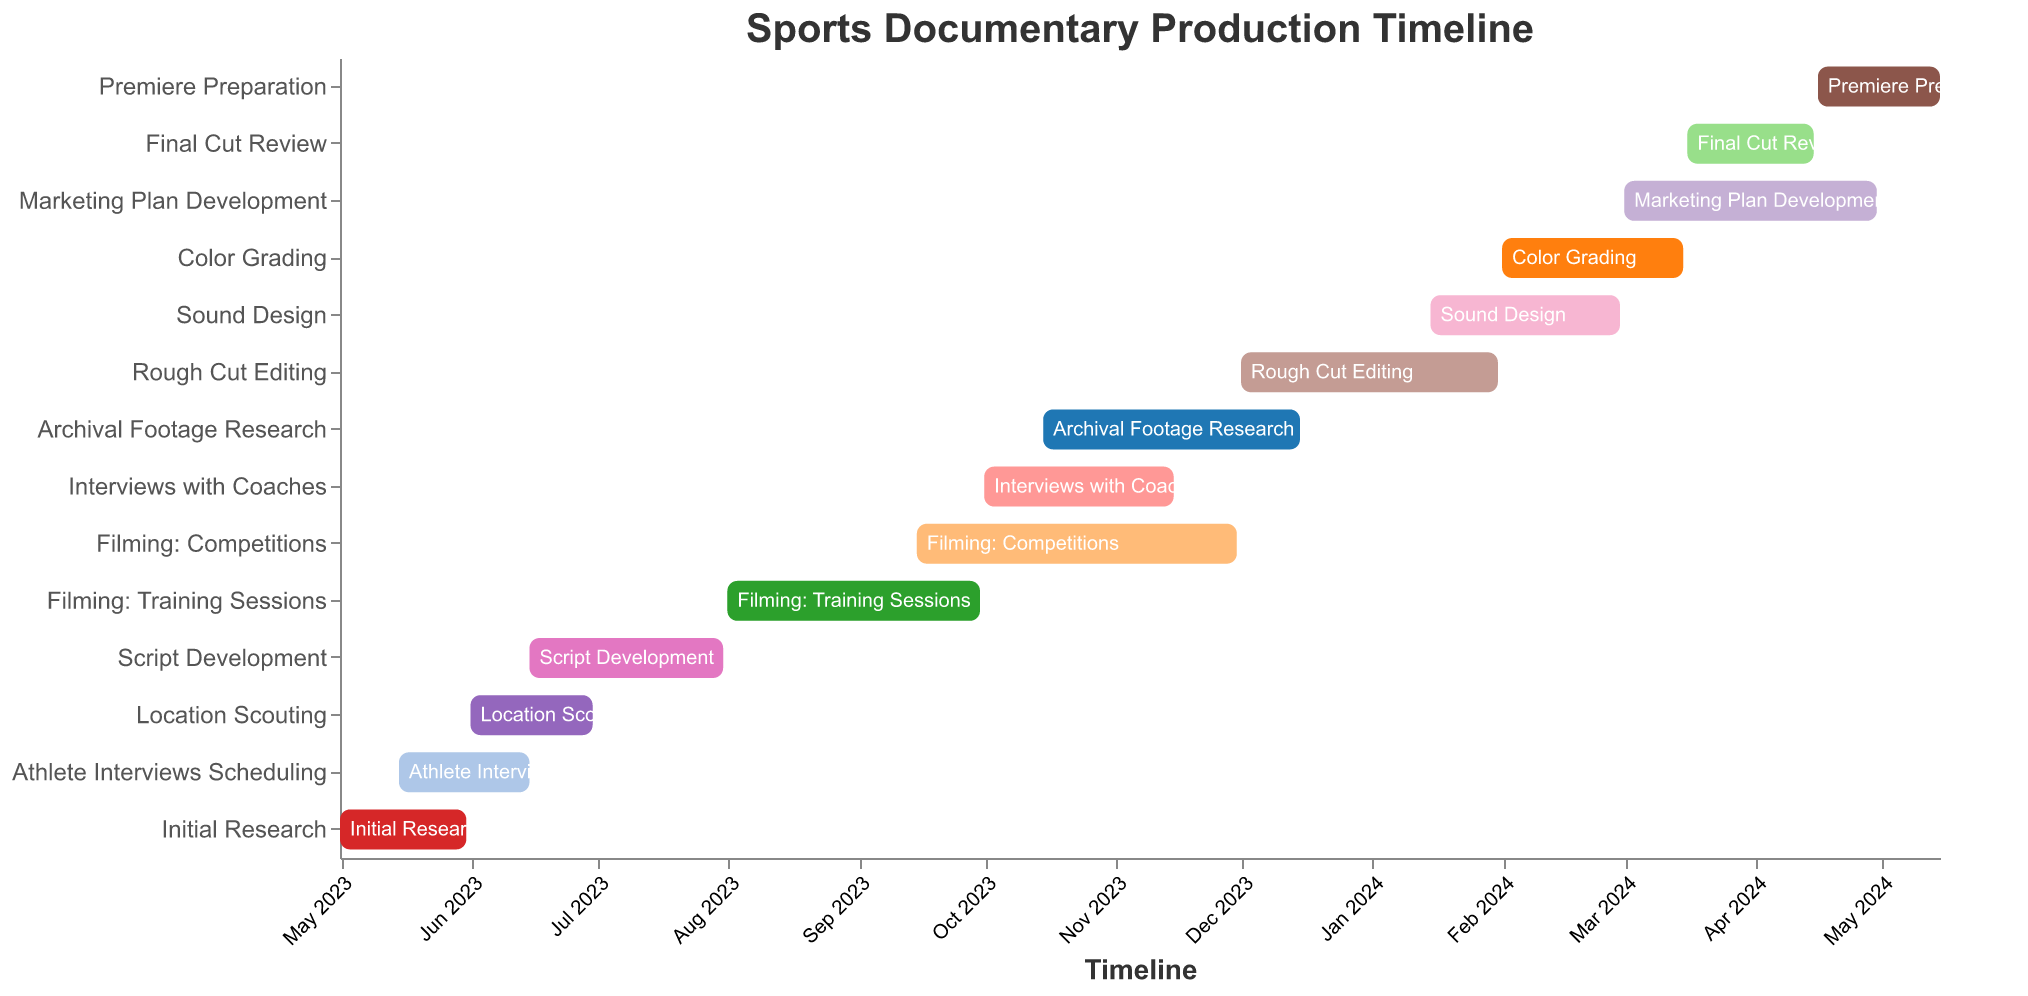What is the title of the chart? The title is at the top of the chart and it reads "Sports Documentary Production Timeline".
Answer: Sports Documentary Production Timeline Which task starts immediately after "Initial Research"? By looking at the Gantt chart, "Athlete Interviews Scheduling" starts on 2023-05-15 which is within the period of "Initial Research". The next new task to start after "Initial Research" ends on 2023-05-31 is "Location Scouting" starting on 2023-06-01.
Answer: Location Scouting How long does the "Script Development" phase last? According to the Gantt Chart, the "Script Development" phase starts on 2023-06-15 and ends on 2023-07-31. The number of days between these two dates is 46 days.
Answer: 46 days Which task lasts the longest and how long is it? By comparing the duration (end date - start date) of all tasks, "Filming: Competitions" has the longest duration, from 2023-09-15 to 2023-11-30, lasting 76 days.
Answer: Filming: Competitions, 76 days Which two tasks overlap entirely? Looking at the chart, "Interviews with Coaches" (2023-10-01 to 2023-11-15) and "Filming: Competitions" (2023-09-15 to 2023-11-30) have overlapping periods but none overlap entirely. Next overlapping tasks are "Sound Design" (2024-01-15 to 2024-02-29) and "Rough Cut Editing" (2023-12-01 to 2024-01-31)
Answer: None entirely but "Sound Design" and "Rough Cut Editing" do overlap What is the total duration of the production timeline? The entire timeline stretches from the start date of "Initial Research" (2023-05-01) to the end date of "Premiere Preparation" (2024-05-15). This spans 381 days in total.
Answer: 381 days Which task starts first and which one ends last? The first task, "Initial Research", starts on 2023-05-01, and the last task, "Premiere Preparation", ends on 2024-05-15.
Answer: Initial Research; Premiere Preparation Does "Final Cut Review" overlap with "Marketing Plan Development"? Checking both "Final Cut Review" (2024-03-16 to 2024-04-15) and "Marketing Plan Development" (2024-03-01 to 2024-04-30), there is an overlap between these two tasks from 2024-03-16 to 2024-04-15.
Answer: Yes How many tasks fall under the post-production phase? Based on the chart, tasks starting from "Rough Cut Editing" onward can be considered post-production. They are "Rough Cut Editing," "Sound Design," "Color Grading," "Final Cut Review," "Marketing Plan Development," and "Premiere Preparation" which totals to 6 tasks.
Answer: 6 tasks 